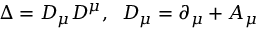<formula> <loc_0><loc_0><loc_500><loc_500>\Delta = D _ { \mu } D ^ { \mu } , \, D _ { \mu } = \partial _ { \mu } + A _ { \mu }</formula> 